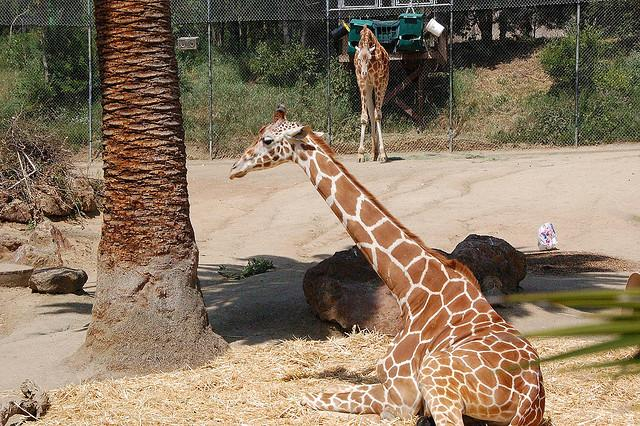What state of mind is the giraffe most likely in? Please explain your reasoning. relaxed. The giraffe is lying on the ground, resting so it would be in a docile, happy mood. 